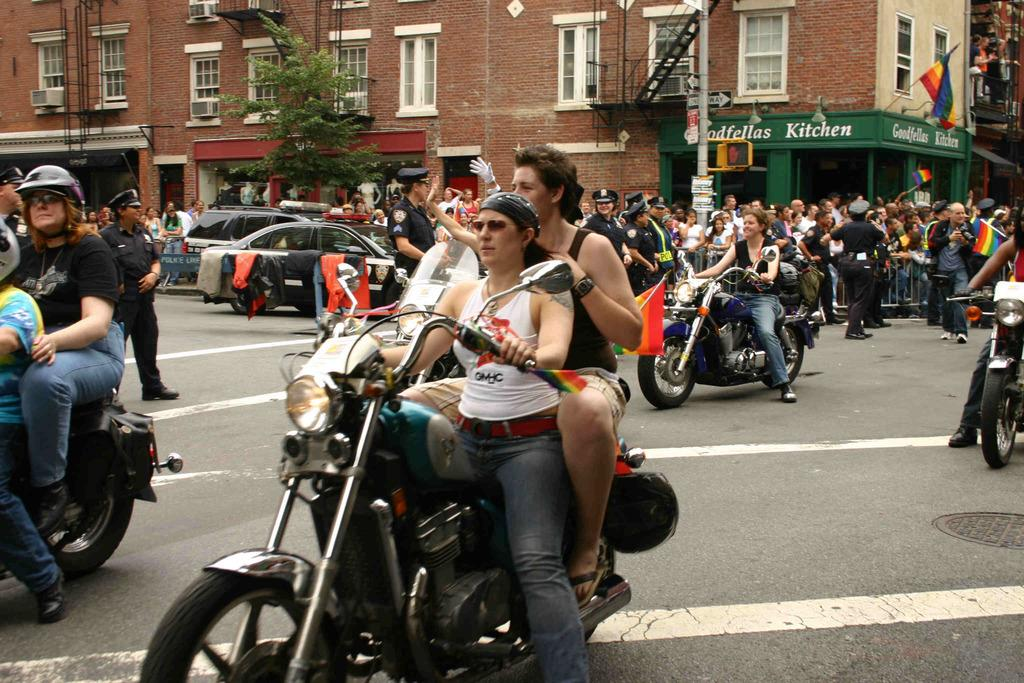Where was the image taken? The image is taken outdoors. What is the weather like in the image? It is sunny in the image. What are the people in the image doing? There is a group of people riding bikes on a road. What can be seen behind the people on the road? There are cars parked behind the people on the road. What is visible in the background of the image? Trees and a building are visible in the background of the image. What type of fuel is being used by the pail in the image? There is no pail present in the image, so it is not possible to determine what type of fuel it might be using. Can you tell me how many berries are on the tree in the image? There are no berries or trees with berries visible in the image. 